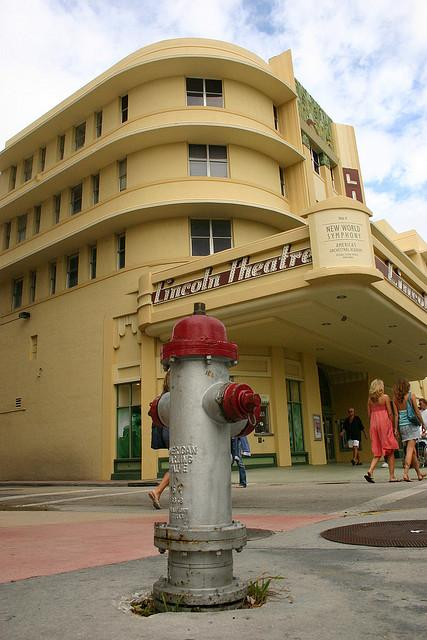What could someone do inside the yellow building? watch movie 